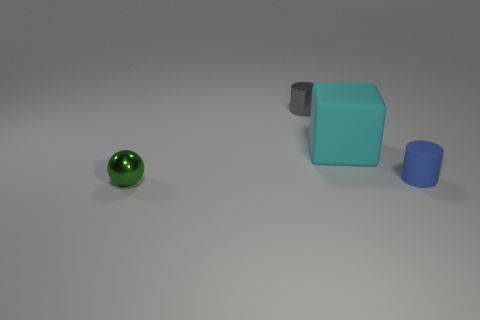Add 4 big green shiny objects. How many objects exist? 8 Subtract all balls. How many objects are left? 3 Subtract 0 purple cylinders. How many objects are left? 4 Subtract all cyan rubber things. Subtract all large things. How many objects are left? 2 Add 2 small blue things. How many small blue things are left? 3 Add 3 small purple metal cylinders. How many small purple metal cylinders exist? 3 